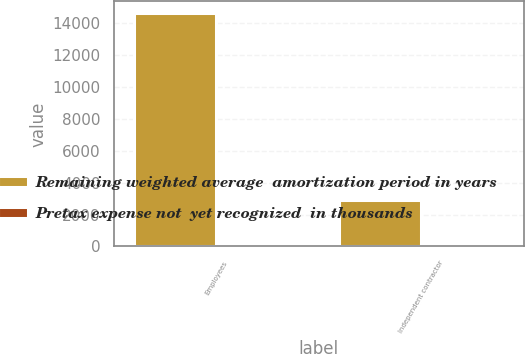Convert chart. <chart><loc_0><loc_0><loc_500><loc_500><stacked_bar_chart><ecel><fcel>Employees<fcel>Independent contractor<nl><fcel>Remaining weighted average  amortization period in years<fcel>14655<fcel>2904<nl><fcel>Pretax expense not  yet recognized  in thousands<fcel>2.5<fcel>3<nl></chart> 